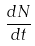Convert formula to latex. <formula><loc_0><loc_0><loc_500><loc_500>\frac { d N } { d t }</formula> 